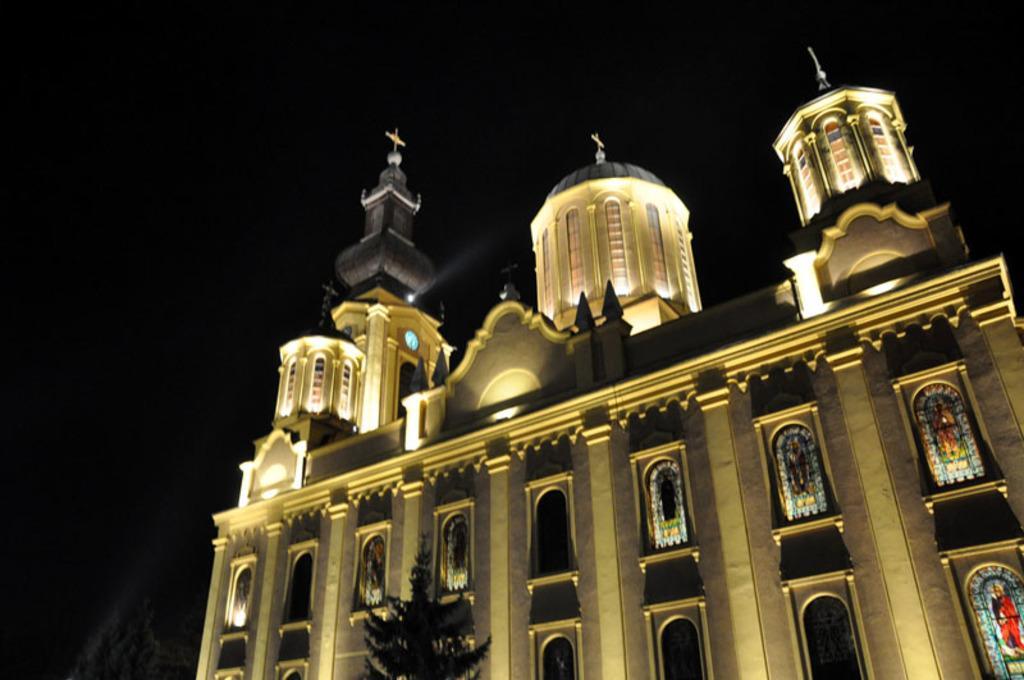In one or two sentences, can you explain what this image depicts? In this image I can see a building in cream and brown color and I can see dark background. 